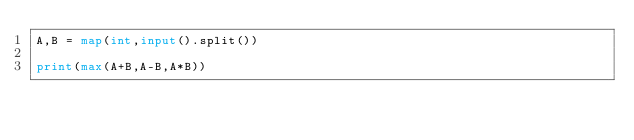Convert code to text. <code><loc_0><loc_0><loc_500><loc_500><_Python_>A,B = map(int,input().split())

print(max(A+B,A-B,A*B))</code> 